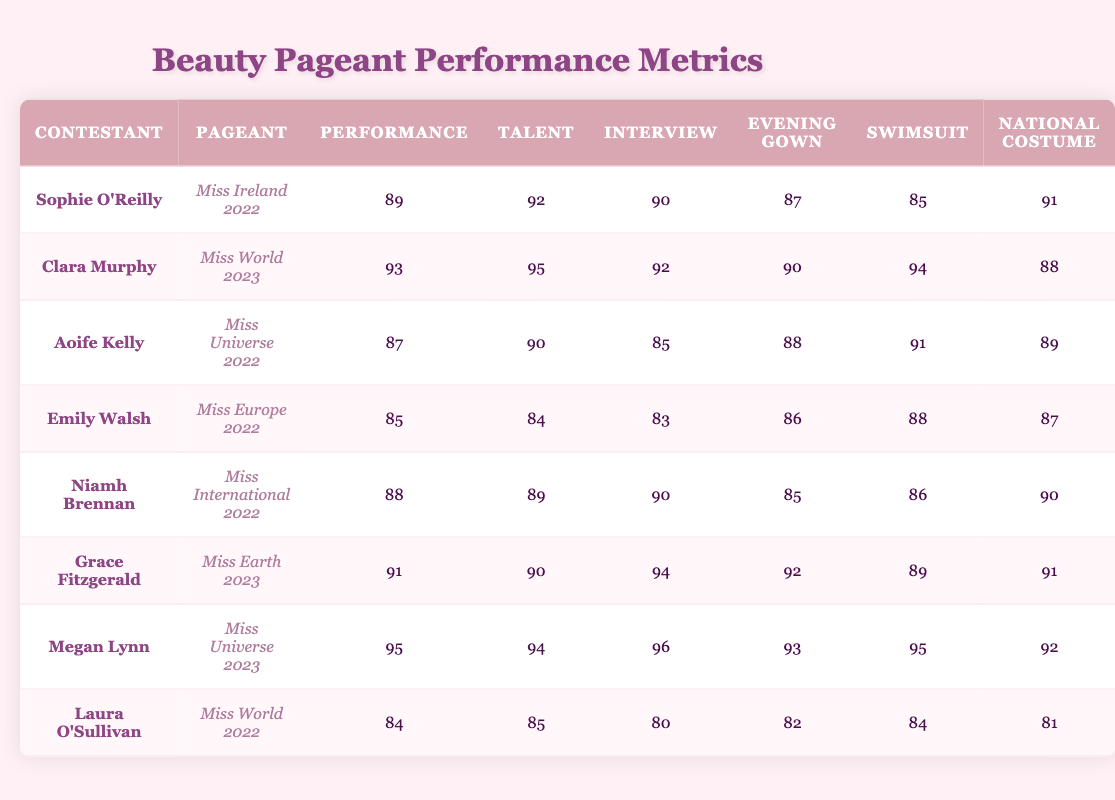What is the performance score of Megan Lynn in Miss Universe 2023? According to the table, Megan Lynn's performance score in Miss Universe 2023 is listed as 95.
Answer: 95 Which contestant has the highest talent score and what is that score? By examining the talent scores in the table, Clara Murphy has the highest talent score of 95 in Miss World 2023.
Answer: Clara Murphy, 95 Is Niamh Brennan's evening gown score higher than her swimsuit score? Niamh Brennan's evening gown score is 85, and her swimsuit score is 86. Since 85 is not higher than 86, the statement is false.
Answer: No What is the average interview score of all contestants? To find the average interview score, we sum the individual scores: (90 + 92 + 85 + 83 + 90 + 94 + 96 + 80) = 720. There are 8 contestants, so the average is 720/8 = 90.
Answer: 90 Which contestant has the lowest performance score and what is it? Looking at the performance scores, Emily Walsh has the lowest score at 85 in Miss Europe 2022.
Answer: Emily Walsh, 85 Is it true that Sophie O'Reilly scored higher in the swimsuit category than Laura O'Sullivan? Sophie O'Reilly's swimsuit score is 85, while Laura O'Sullivan's is 84. Since 85 is greater than 84, the statement is true.
Answer: Yes Which Miss World contestant had the highest overall score? Among the contestants listed for Miss World, Clara Murphy has the highest performance score of 93 in Miss World 2023, which is also the highest overall score compared to other pageants.
Answer: Clara Murphy, 93 What is the total score of Grace Fitzgerald across all categories? To calculate Grace Fitzgerald's total score, we add all her scores: 91 + 90 + 94 + 92 + 89 + 91 = 547.
Answer: 547 Is Aoife Kelly's talent score lower than Niamh Brennan's talent score? Aoife Kelly's talent score is 90 while Niamh Brennan's talent score is 89. Thus, Aoife Kelly's talent score is higher than Niamh Brennan's. Therefore, the statement is false.
Answer: No 